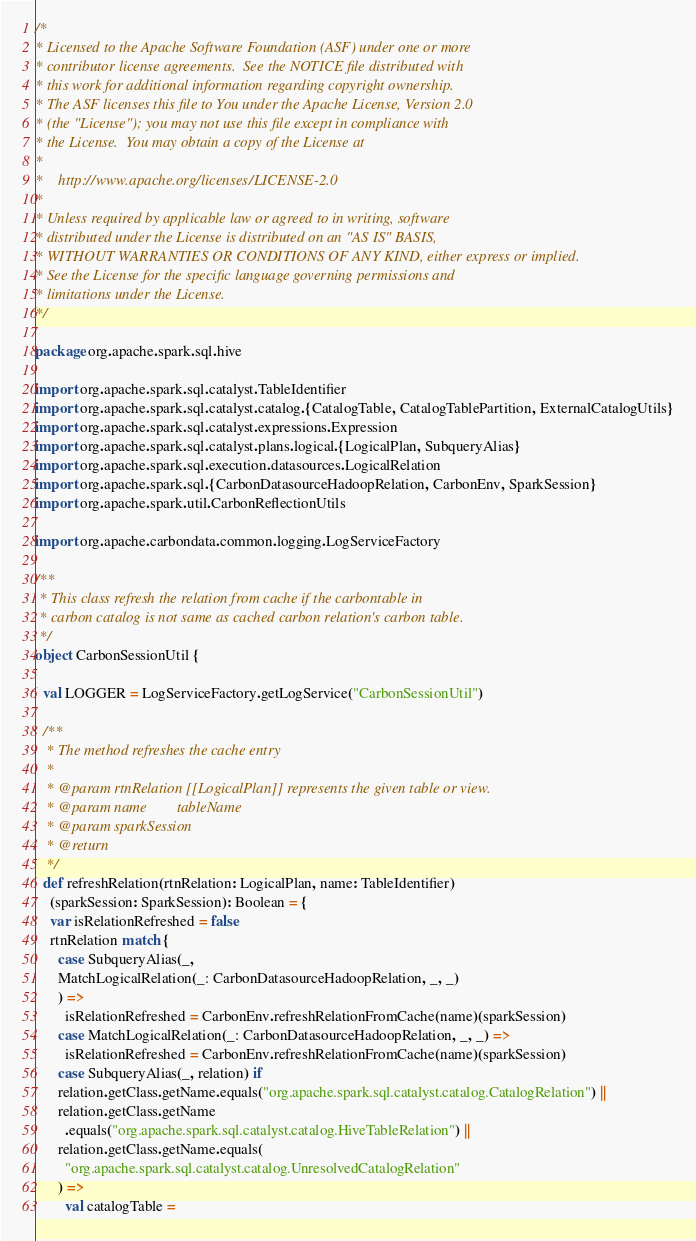<code> <loc_0><loc_0><loc_500><loc_500><_Scala_>/*
* Licensed to the Apache Software Foundation (ASF) under one or more
* contributor license agreements.  See the NOTICE file distributed with
* this work for additional information regarding copyright ownership.
* The ASF licenses this file to You under the Apache License, Version 2.0
* (the "License"); you may not use this file except in compliance with
* the License.  You may obtain a copy of the License at
*
*    http://www.apache.org/licenses/LICENSE-2.0
*
* Unless required by applicable law or agreed to in writing, software
* distributed under the License is distributed on an "AS IS" BASIS,
* WITHOUT WARRANTIES OR CONDITIONS OF ANY KIND, either express or implied.
* See the License for the specific language governing permissions and
* limitations under the License.
*/

package org.apache.spark.sql.hive

import org.apache.spark.sql.catalyst.TableIdentifier
import org.apache.spark.sql.catalyst.catalog.{CatalogTable, CatalogTablePartition, ExternalCatalogUtils}
import org.apache.spark.sql.catalyst.expressions.Expression
import org.apache.spark.sql.catalyst.plans.logical.{LogicalPlan, SubqueryAlias}
import org.apache.spark.sql.execution.datasources.LogicalRelation
import org.apache.spark.sql.{CarbonDatasourceHadoopRelation, CarbonEnv, SparkSession}
import org.apache.spark.util.CarbonReflectionUtils

import org.apache.carbondata.common.logging.LogServiceFactory

/**
 * This class refresh the relation from cache if the carbontable in
 * carbon catalog is not same as cached carbon relation's carbon table.
 */
object CarbonSessionUtil {

  val LOGGER = LogServiceFactory.getLogService("CarbonSessionUtil")

  /**
   * The method refreshes the cache entry
   *
   * @param rtnRelation [[LogicalPlan]] represents the given table or view.
   * @param name        tableName
   * @param sparkSession
   * @return
   */
  def refreshRelation(rtnRelation: LogicalPlan, name: TableIdentifier)
    (sparkSession: SparkSession): Boolean = {
    var isRelationRefreshed = false
    rtnRelation match {
      case SubqueryAlias(_,
      MatchLogicalRelation(_: CarbonDatasourceHadoopRelation, _, _)
      ) =>
        isRelationRefreshed = CarbonEnv.refreshRelationFromCache(name)(sparkSession)
      case MatchLogicalRelation(_: CarbonDatasourceHadoopRelation, _, _) =>
        isRelationRefreshed = CarbonEnv.refreshRelationFromCache(name)(sparkSession)
      case SubqueryAlias(_, relation) if
      relation.getClass.getName.equals("org.apache.spark.sql.catalyst.catalog.CatalogRelation") ||
      relation.getClass.getName
        .equals("org.apache.spark.sql.catalyst.catalog.HiveTableRelation") ||
      relation.getClass.getName.equals(
        "org.apache.spark.sql.catalyst.catalog.UnresolvedCatalogRelation"
      ) =>
        val catalogTable =</code> 